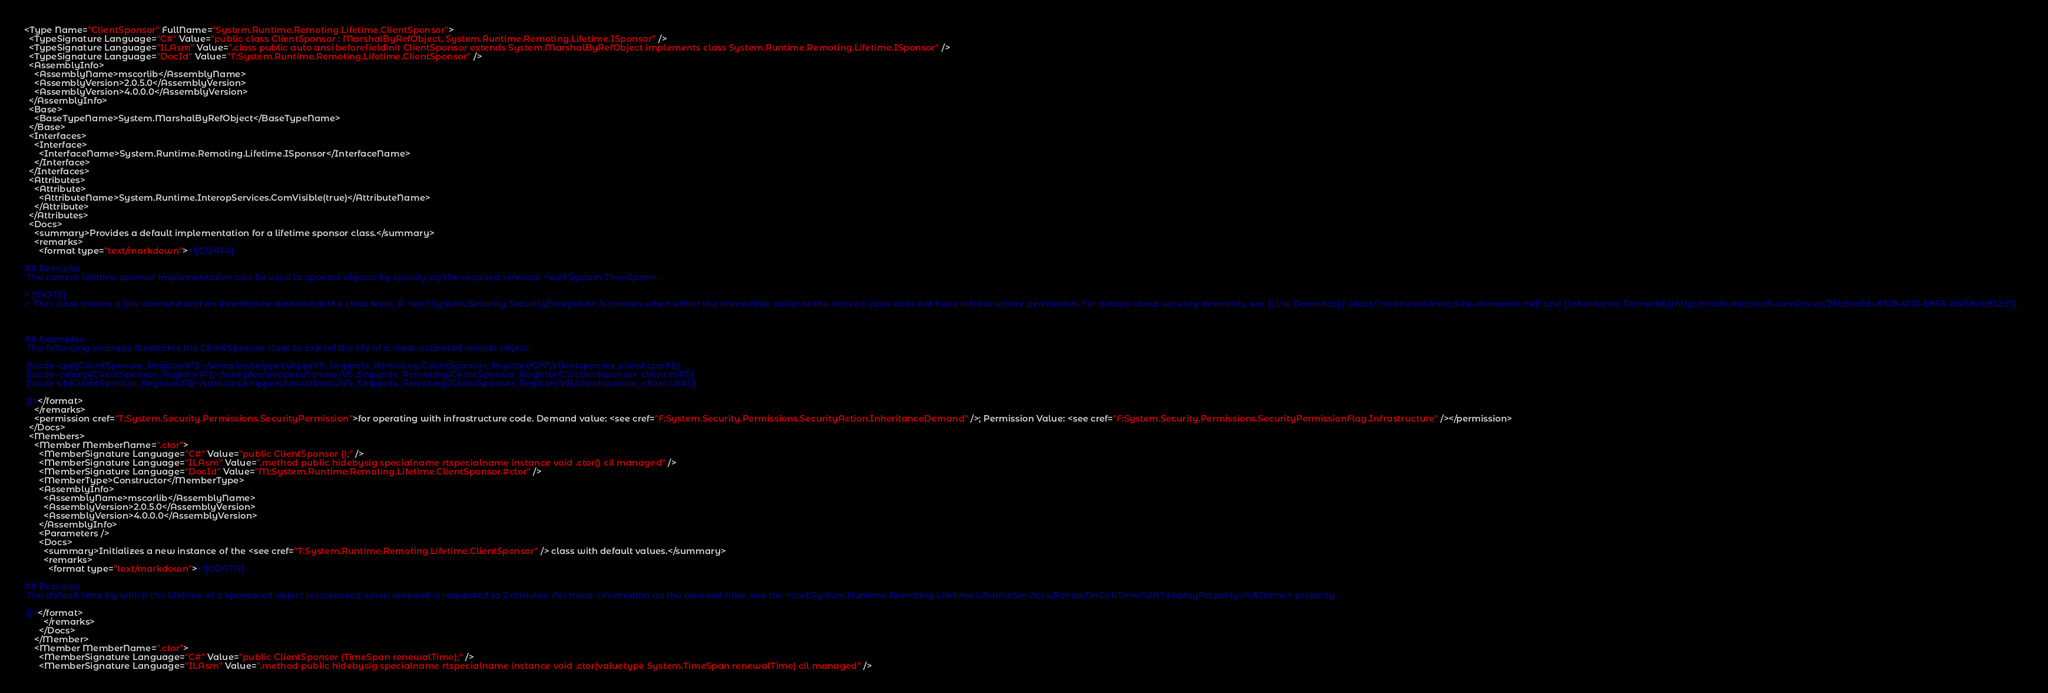Convert code to text. <code><loc_0><loc_0><loc_500><loc_500><_XML_><Type Name="ClientSponsor" FullName="System.Runtime.Remoting.Lifetime.ClientSponsor">
  <TypeSignature Language="C#" Value="public class ClientSponsor : MarshalByRefObject, System.Runtime.Remoting.Lifetime.ISponsor" />
  <TypeSignature Language="ILAsm" Value=".class public auto ansi beforefieldinit ClientSponsor extends System.MarshalByRefObject implements class System.Runtime.Remoting.Lifetime.ISponsor" />
  <TypeSignature Language="DocId" Value="T:System.Runtime.Remoting.Lifetime.ClientSponsor" />
  <AssemblyInfo>
    <AssemblyName>mscorlib</AssemblyName>
    <AssemblyVersion>2.0.5.0</AssemblyVersion>
    <AssemblyVersion>4.0.0.0</AssemblyVersion>
  </AssemblyInfo>
  <Base>
    <BaseTypeName>System.MarshalByRefObject</BaseTypeName>
  </Base>
  <Interfaces>
    <Interface>
      <InterfaceName>System.Runtime.Remoting.Lifetime.ISponsor</InterfaceName>
    </Interface>
  </Interfaces>
  <Attributes>
    <Attribute>
      <AttributeName>System.Runtime.InteropServices.ComVisible(true)</AttributeName>
    </Attribute>
  </Attributes>
  <Docs>
    <summary>Provides a default implementation for a lifetime sponsor class.</summary>
    <remarks>
      <format type="text/markdown"><![CDATA[  
  
## Remarks  
 The current lifetime sponsor implementation can be used to sponsor objects by specifying the required renewal <xref:System.TimeSpan>.  
  
> [!NOTE]
>  This class makes a link demand and an inheritance demand at the class level. A <xref:System.Security.SecurityException> is thrown when either the immediate caller or the derived class does not have infrastructure permission. For details about security demands, see [Link Demands](~/docs/framework/misc/link-demands.md) and [Inheritance Demands](http://msdn.microsoft.com/en-us/28b9adbb-8f08-4f10-b856-dbf59eb932d9).  
  
   
  
## Examples  
 The following example illustrates the ClientSponsor class to extend the life of a class-activated remote object.  
  
 [!code-cpp[ClientSponsor_Register#1](~/samples/snippets/cpp/VS_Snippets_Remoting/ClientSponsor_Register/CPP/clientsponsor_client.cpp#1)]
 [!code-csharp[ClientSponsor_Register#1](~/samples/snippets/csharp/VS_Snippets_Remoting/ClientSponsor_Register/CS/clientsponsor_client.cs#1)]
 [!code-vb[ClientSponsor_Register#1](~/samples/snippets/visualbasic/VS_Snippets_Remoting/ClientSponsor_Register/VB/clientsponsor_client.vb#1)]  
  
 ]]></format>
    </remarks>
    <permission cref="T:System.Security.Permissions.SecurityPermission">for operating with infrastructure code. Demand value: <see cref="F:System.Security.Permissions.SecurityAction.InheritanceDemand" />; Permission Value: <see cref="F:System.Security.Permissions.SecurityPermissionFlag.Infrastructure" /></permission>
  </Docs>
  <Members>
    <Member MemberName=".ctor">
      <MemberSignature Language="C#" Value="public ClientSponsor ();" />
      <MemberSignature Language="ILAsm" Value=".method public hidebysig specialname rtspecialname instance void .ctor() cil managed" />
      <MemberSignature Language="DocId" Value="M:System.Runtime.Remoting.Lifetime.ClientSponsor.#ctor" />
      <MemberType>Constructor</MemberType>
      <AssemblyInfo>
        <AssemblyName>mscorlib</AssemblyName>
        <AssemblyVersion>2.0.5.0</AssemblyVersion>
        <AssemblyVersion>4.0.0.0</AssemblyVersion>
      </AssemblyInfo>
      <Parameters />
      <Docs>
        <summary>Initializes a new instance of the <see cref="T:System.Runtime.Remoting.Lifetime.ClientSponsor" /> class with default values.</summary>
        <remarks>
          <format type="text/markdown"><![CDATA[  
  
## Remarks  
 The default time by which the lifetime of a sponsored object is increased when renewal is requested to 2 minutes. For more information on the renewal time, see the <xref:System.Runtime.Remoting.Lifetime.LifetimeServices.RenewOnCallTime%2A?displayProperty=fullName> property.  
  
 ]]></format>
        </remarks>
      </Docs>
    </Member>
    <Member MemberName=".ctor">
      <MemberSignature Language="C#" Value="public ClientSponsor (TimeSpan renewalTime);" />
      <MemberSignature Language="ILAsm" Value=".method public hidebysig specialname rtspecialname instance void .ctor(valuetype System.TimeSpan renewalTime) cil managed" /></code> 